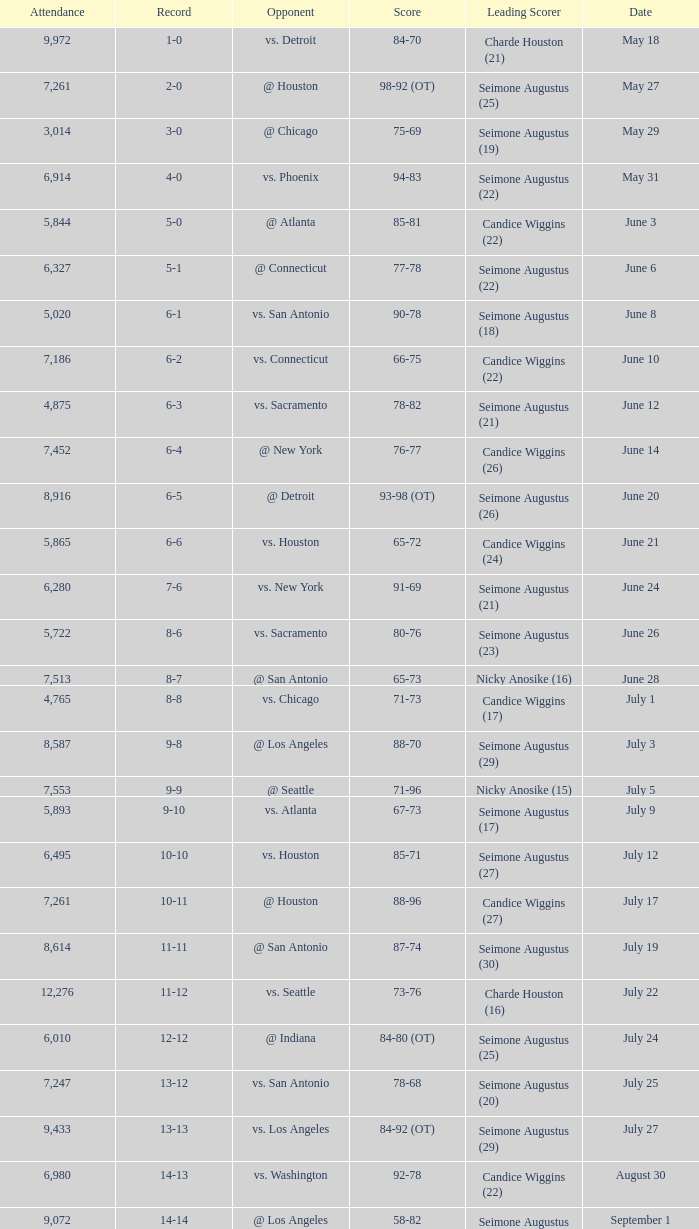Which Leading Scorer has an Opponent of @ seattle, and a Record of 14-16? Seimone Augustus (26). 